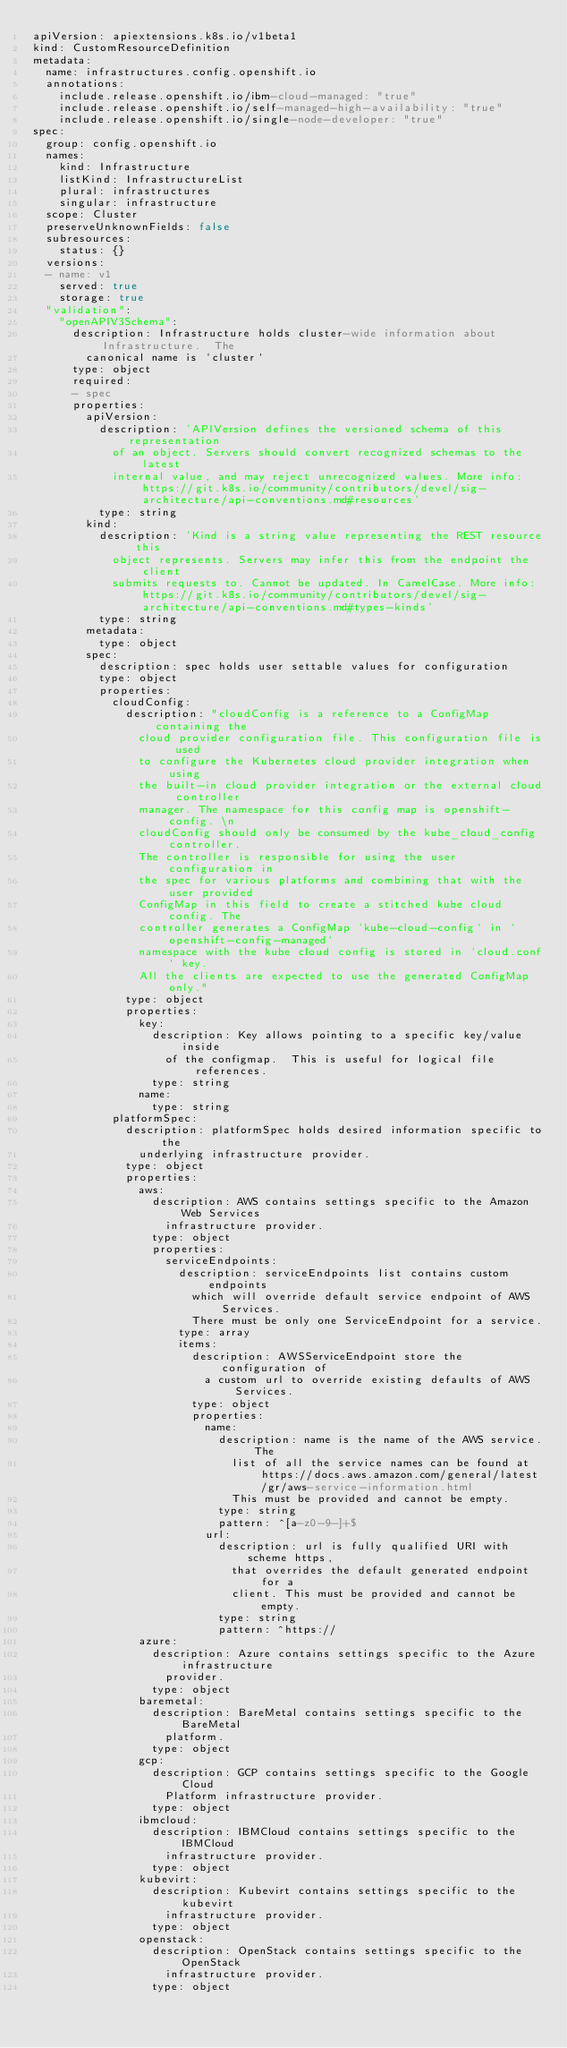<code> <loc_0><loc_0><loc_500><loc_500><_YAML_>apiVersion: apiextensions.k8s.io/v1beta1
kind: CustomResourceDefinition
metadata:
  name: infrastructures.config.openshift.io
  annotations:
    include.release.openshift.io/ibm-cloud-managed: "true"
    include.release.openshift.io/self-managed-high-availability: "true"
    include.release.openshift.io/single-node-developer: "true"
spec:
  group: config.openshift.io
  names:
    kind: Infrastructure
    listKind: InfrastructureList
    plural: infrastructures
    singular: infrastructure
  scope: Cluster
  preserveUnknownFields: false
  subresources:
    status: {}
  versions:
  - name: v1
    served: true
    storage: true
  "validation":
    "openAPIV3Schema":
      description: Infrastructure holds cluster-wide information about Infrastructure.  The
        canonical name is `cluster`
      type: object
      required:
      - spec
      properties:
        apiVersion:
          description: 'APIVersion defines the versioned schema of this representation
            of an object. Servers should convert recognized schemas to the latest
            internal value, and may reject unrecognized values. More info: https://git.k8s.io/community/contributors/devel/sig-architecture/api-conventions.md#resources'
          type: string
        kind:
          description: 'Kind is a string value representing the REST resource this
            object represents. Servers may infer this from the endpoint the client
            submits requests to. Cannot be updated. In CamelCase. More info: https://git.k8s.io/community/contributors/devel/sig-architecture/api-conventions.md#types-kinds'
          type: string
        metadata:
          type: object
        spec:
          description: spec holds user settable values for configuration
          type: object
          properties:
            cloudConfig:
              description: "cloudConfig is a reference to a ConfigMap containing the
                cloud provider configuration file. This configuration file is used
                to configure the Kubernetes cloud provider integration when using
                the built-in cloud provider integration or the external cloud controller
                manager. The namespace for this config map is openshift-config. \n
                cloudConfig should only be consumed by the kube_cloud_config controller.
                The controller is responsible for using the user configuration in
                the spec for various platforms and combining that with the user provided
                ConfigMap in this field to create a stitched kube cloud config. The
                controller generates a ConfigMap `kube-cloud-config` in `openshift-config-managed`
                namespace with the kube cloud config is stored in `cloud.conf` key.
                All the clients are expected to use the generated ConfigMap only."
              type: object
              properties:
                key:
                  description: Key allows pointing to a specific key/value inside
                    of the configmap.  This is useful for logical file references.
                  type: string
                name:
                  type: string
            platformSpec:
              description: platformSpec holds desired information specific to the
                underlying infrastructure provider.
              type: object
              properties:
                aws:
                  description: AWS contains settings specific to the Amazon Web Services
                    infrastructure provider.
                  type: object
                  properties:
                    serviceEndpoints:
                      description: serviceEndpoints list contains custom endpoints
                        which will override default service endpoint of AWS Services.
                        There must be only one ServiceEndpoint for a service.
                      type: array
                      items:
                        description: AWSServiceEndpoint store the configuration of
                          a custom url to override existing defaults of AWS Services.
                        type: object
                        properties:
                          name:
                            description: name is the name of the AWS service. The
                              list of all the service names can be found at https://docs.aws.amazon.com/general/latest/gr/aws-service-information.html
                              This must be provided and cannot be empty.
                            type: string
                            pattern: ^[a-z0-9-]+$
                          url:
                            description: url is fully qualified URI with scheme https,
                              that overrides the default generated endpoint for a
                              client. This must be provided and cannot be empty.
                            type: string
                            pattern: ^https://
                azure:
                  description: Azure contains settings specific to the Azure infrastructure
                    provider.
                  type: object
                baremetal:
                  description: BareMetal contains settings specific to the BareMetal
                    platform.
                  type: object
                gcp:
                  description: GCP contains settings specific to the Google Cloud
                    Platform infrastructure provider.
                  type: object
                ibmcloud:
                  description: IBMCloud contains settings specific to the IBMCloud
                    infrastructure provider.
                  type: object
                kubevirt:
                  description: Kubevirt contains settings specific to the kubevirt
                    infrastructure provider.
                  type: object
                openstack:
                  description: OpenStack contains settings specific to the OpenStack
                    infrastructure provider.
                  type: object</code> 